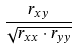Convert formula to latex. <formula><loc_0><loc_0><loc_500><loc_500>\frac { r _ { x y } } { \sqrt { r _ { x x } \cdot r _ { y y } } }</formula> 